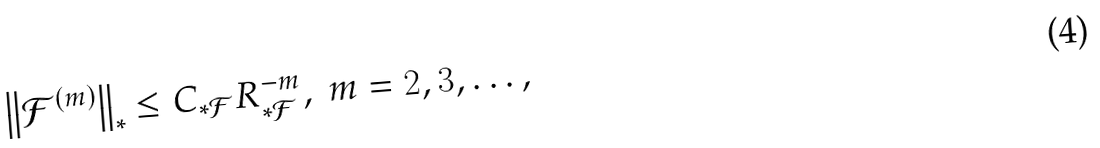Convert formula to latex. <formula><loc_0><loc_0><loc_500><loc_500>\left \| \mathcal { F } ^ { \left ( m \right ) } \right \| _ { \ast } \leq C _ { \ast \mathcal { F } } R _ { \ast \mathcal { F } } ^ { - m } , \ m = 2 , 3 , \dots ,</formula> 